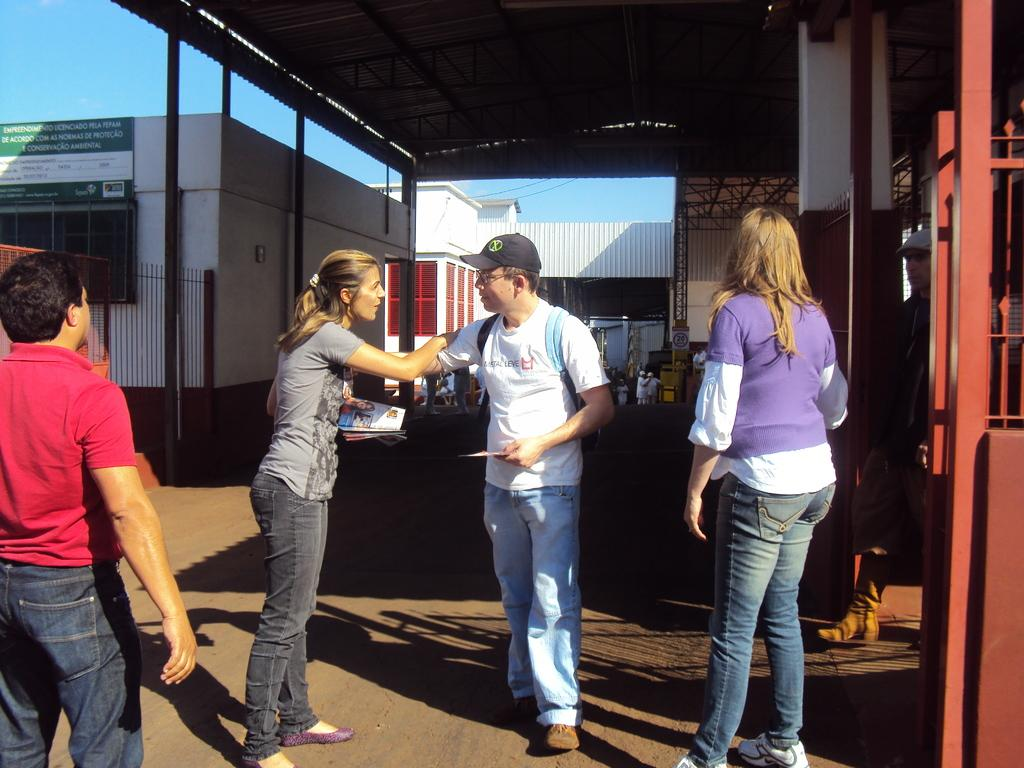What are the people in the image doing? The persons standing on the ground in the image are likely engaged in some activity or gathering. What type of structures can be seen in the image? There are buildings, sheds, and information boards present in the image. What architectural features are visible in the image? Fences are visible in the image. What type of cooking equipment is present in the image? Grills are visible in the image. What part of the natural environment is visible in the image? The sky is visible in the image. Can you see any mountains in the image? There are no mountains visible in the image. Is there a sink present in the image? There is no sink present in the image. 